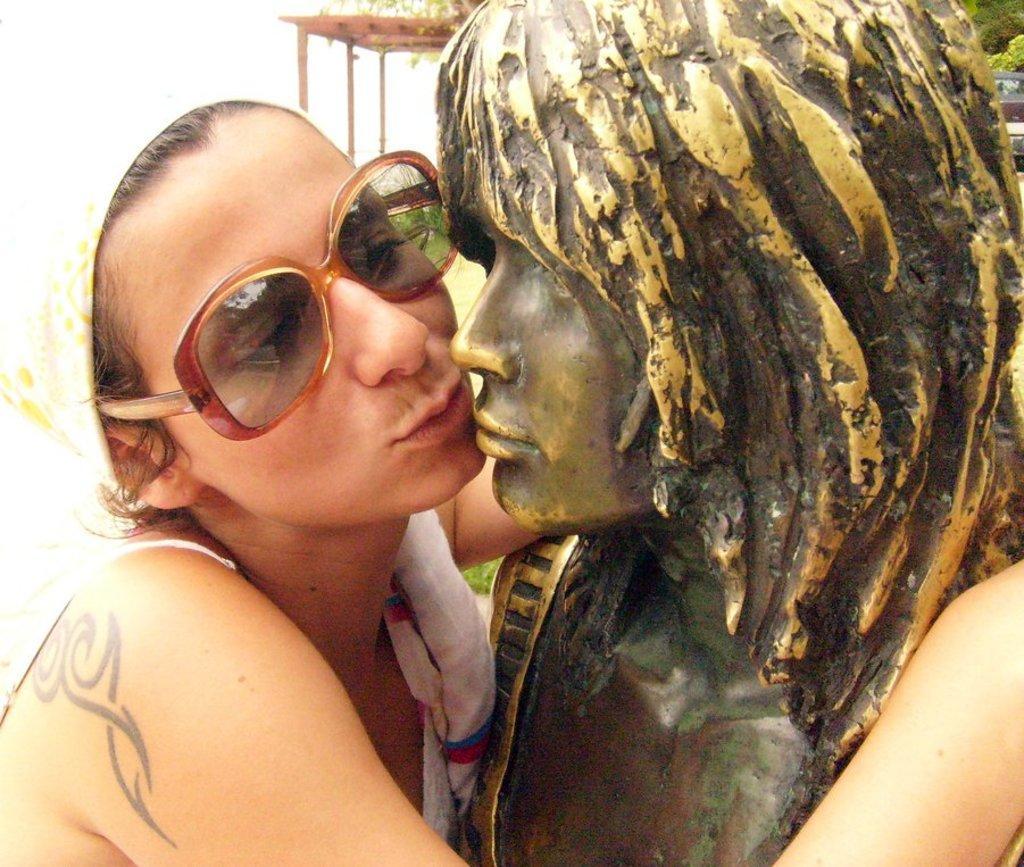Please provide a concise description of this image. In this image we can see a person with goggles is holding a statue and there is a shed in the background. 